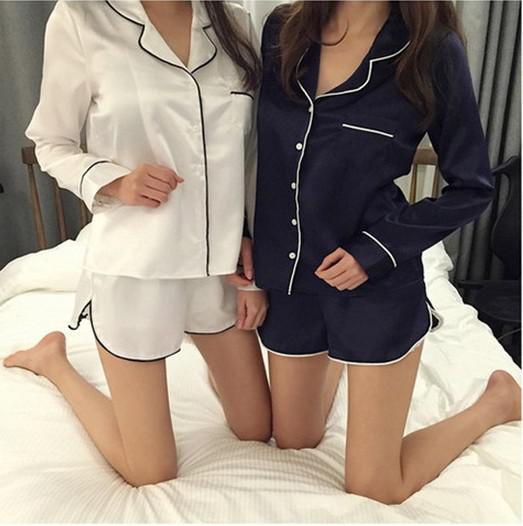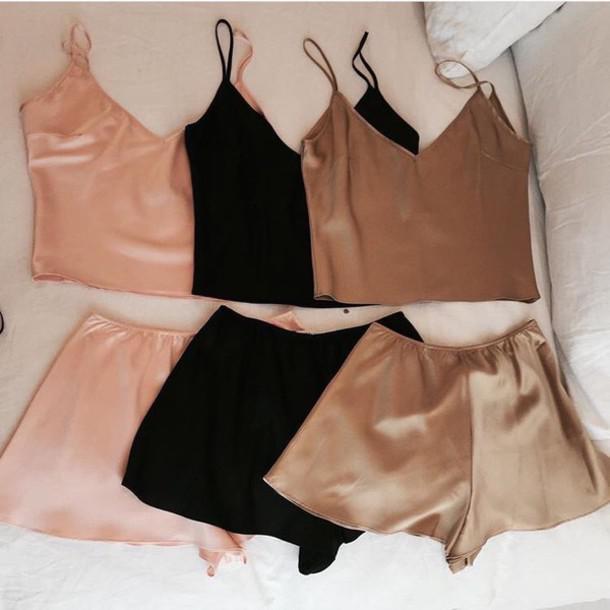The first image is the image on the left, the second image is the image on the right. Considering the images on both sides, is "Images feature matching dark lingerie sets and peachy colored sets, but none are worn by human models." valid? Answer yes or no. No. The first image is the image on the left, the second image is the image on the right. Examine the images to the left and right. Is the description "There is one set of lingerie in the image on the left." accurate? Answer yes or no. No. 